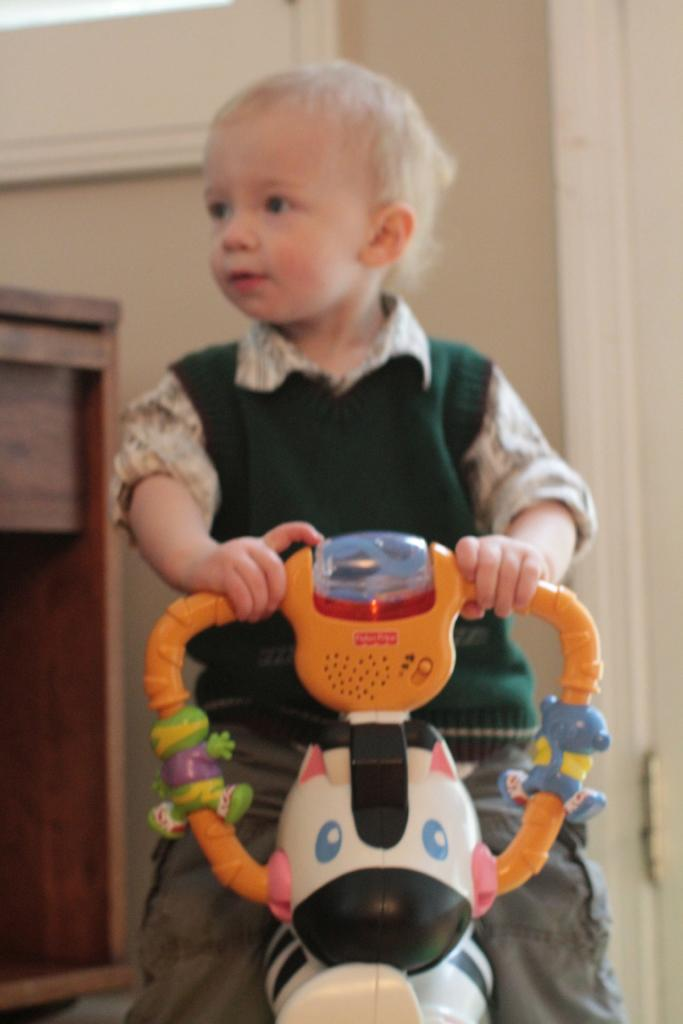What is the main subject in the foreground of the image? There is a kid in the foreground of the image. What is the kid sitting on? The kid is sitting on a toy vehicle. What can be seen in the background of the image? There is a wall, a whiteboard, and a table in the background of the image. What type of grain is being stored in the library in the image? There is no library or grain present in the image. What book is the kid reading while sitting on the toy vehicle? There is no book visible in the image; the kid is simply sitting on the toy vehicle. 